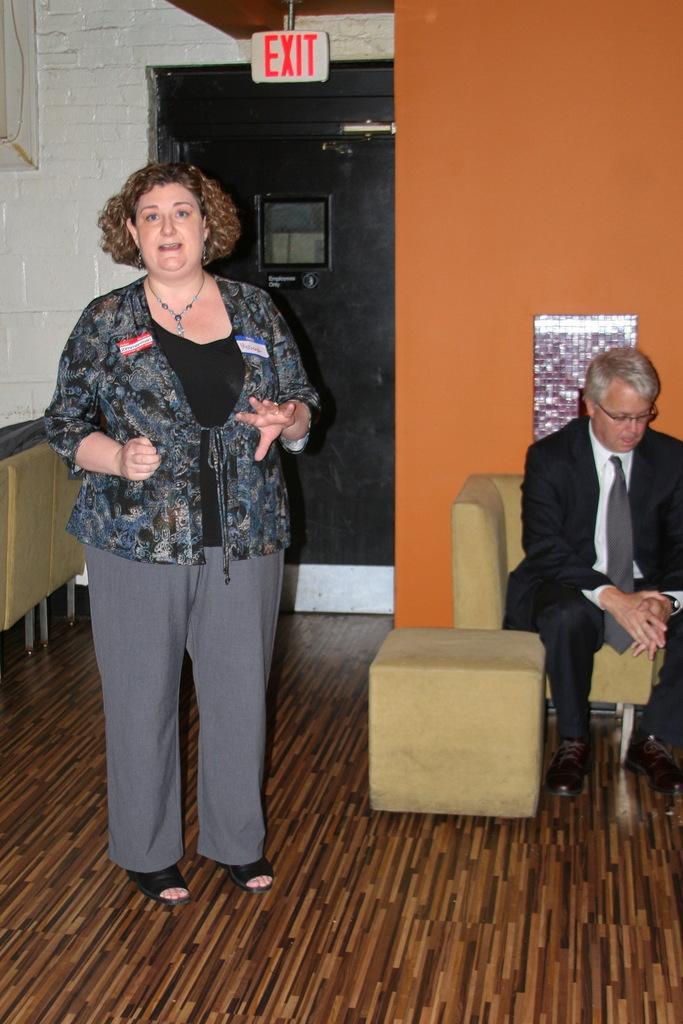Can you describe this image briefly? In this picture, There is a floor which is in brown color and in the left side there is a woman standing and in the right side there is a sofa in yellow color and there is a man sitting on the sofa and in the background there is a wall which is in orange color. 